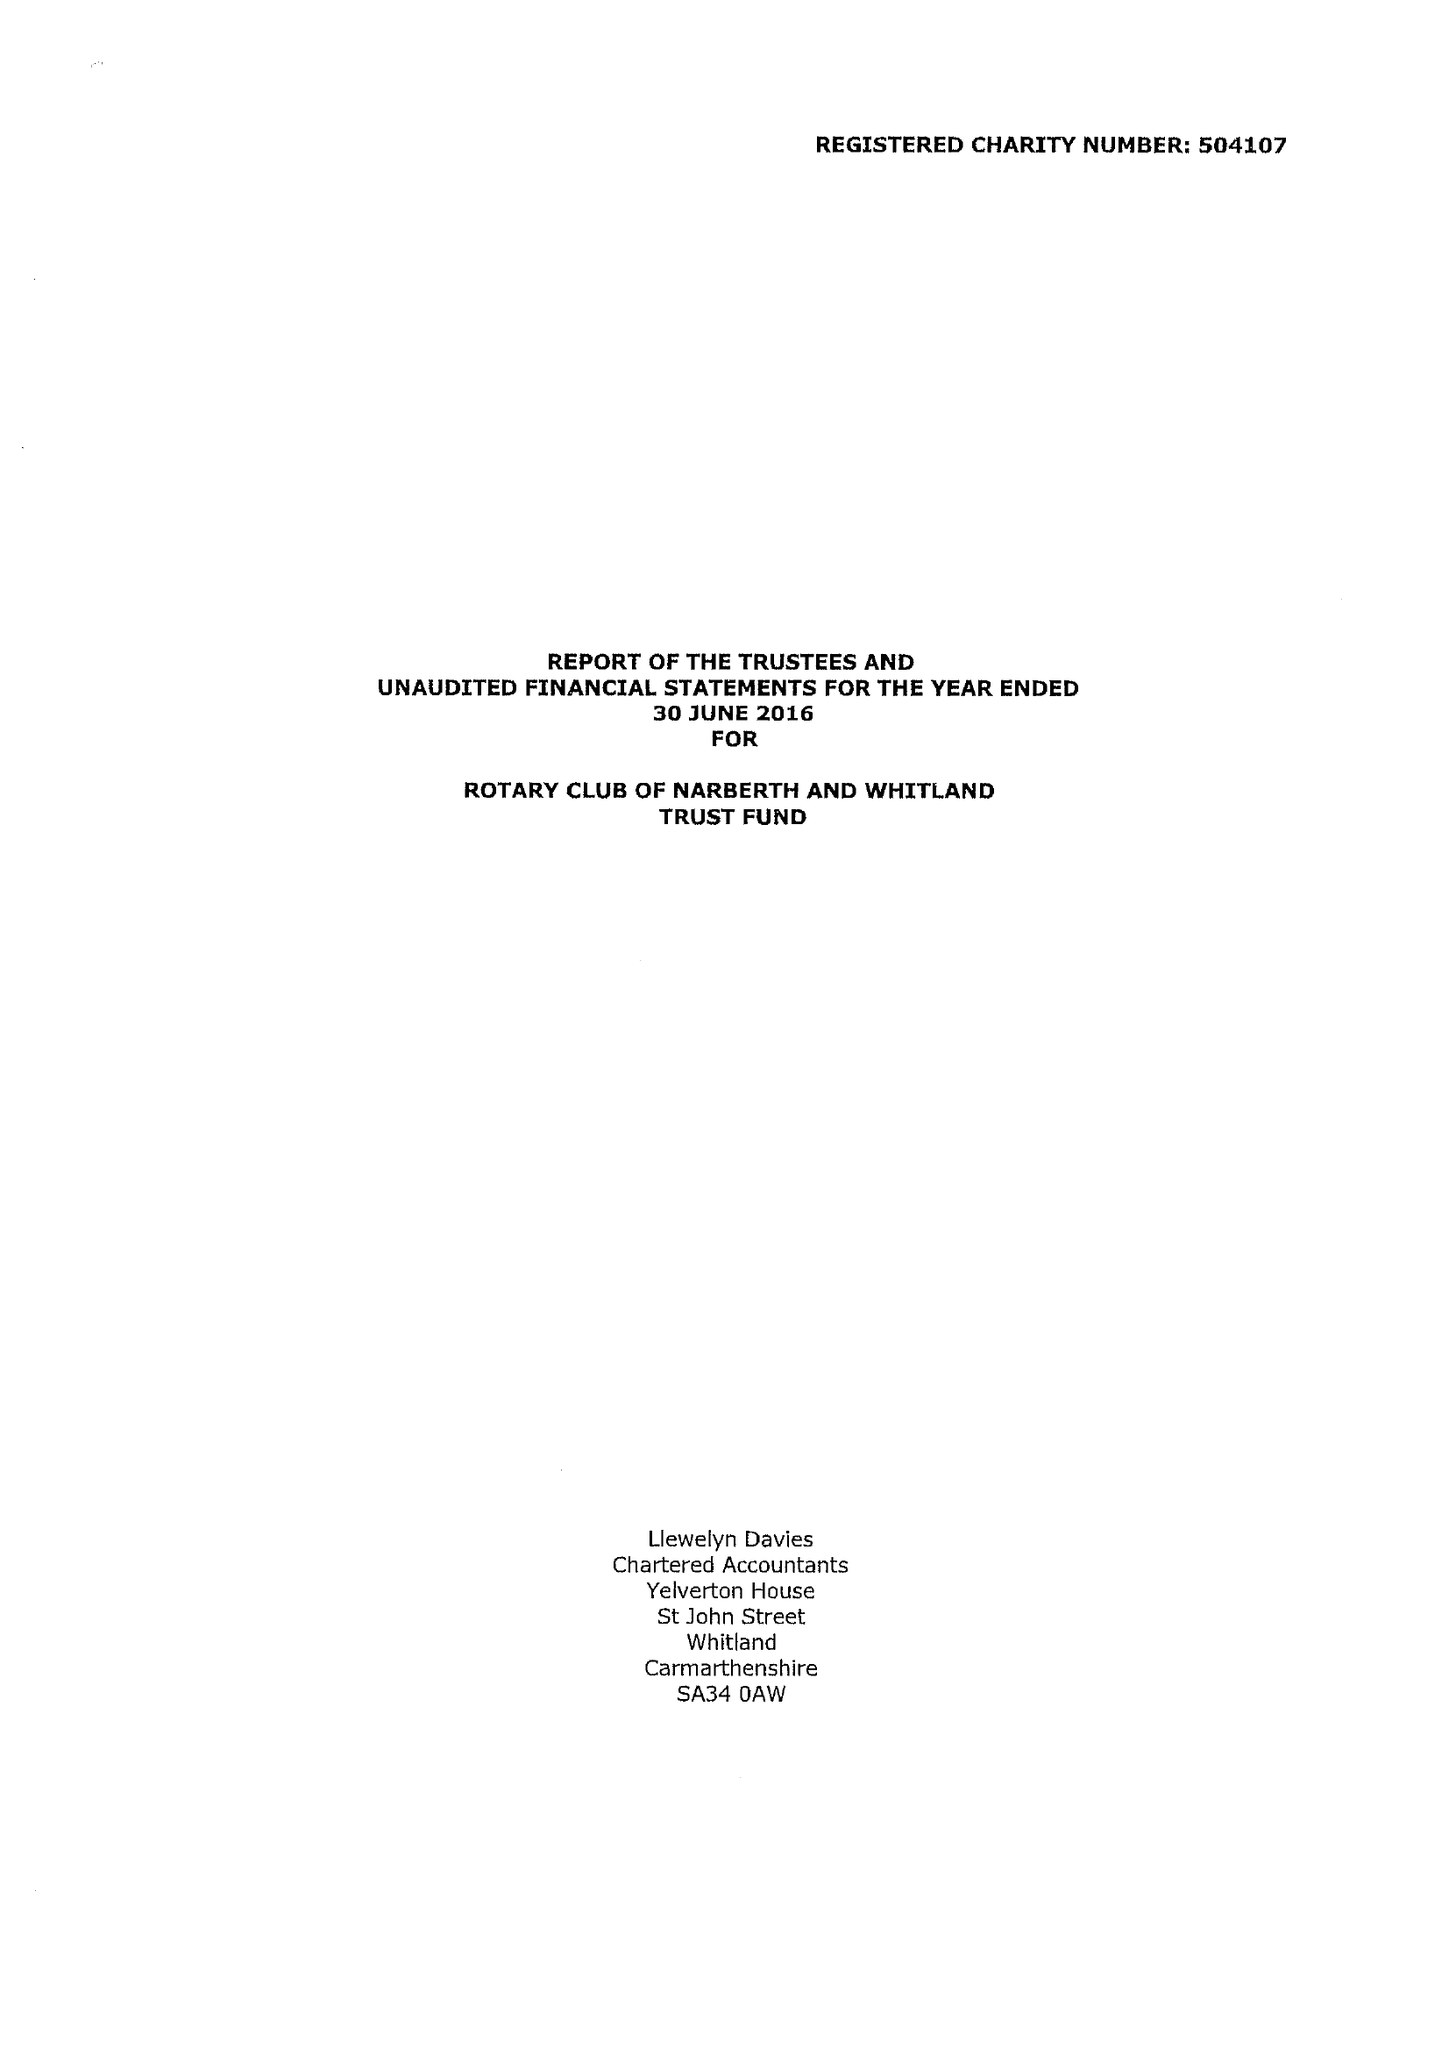What is the value for the spending_annually_in_british_pounds?
Answer the question using a single word or phrase. 45760.00 